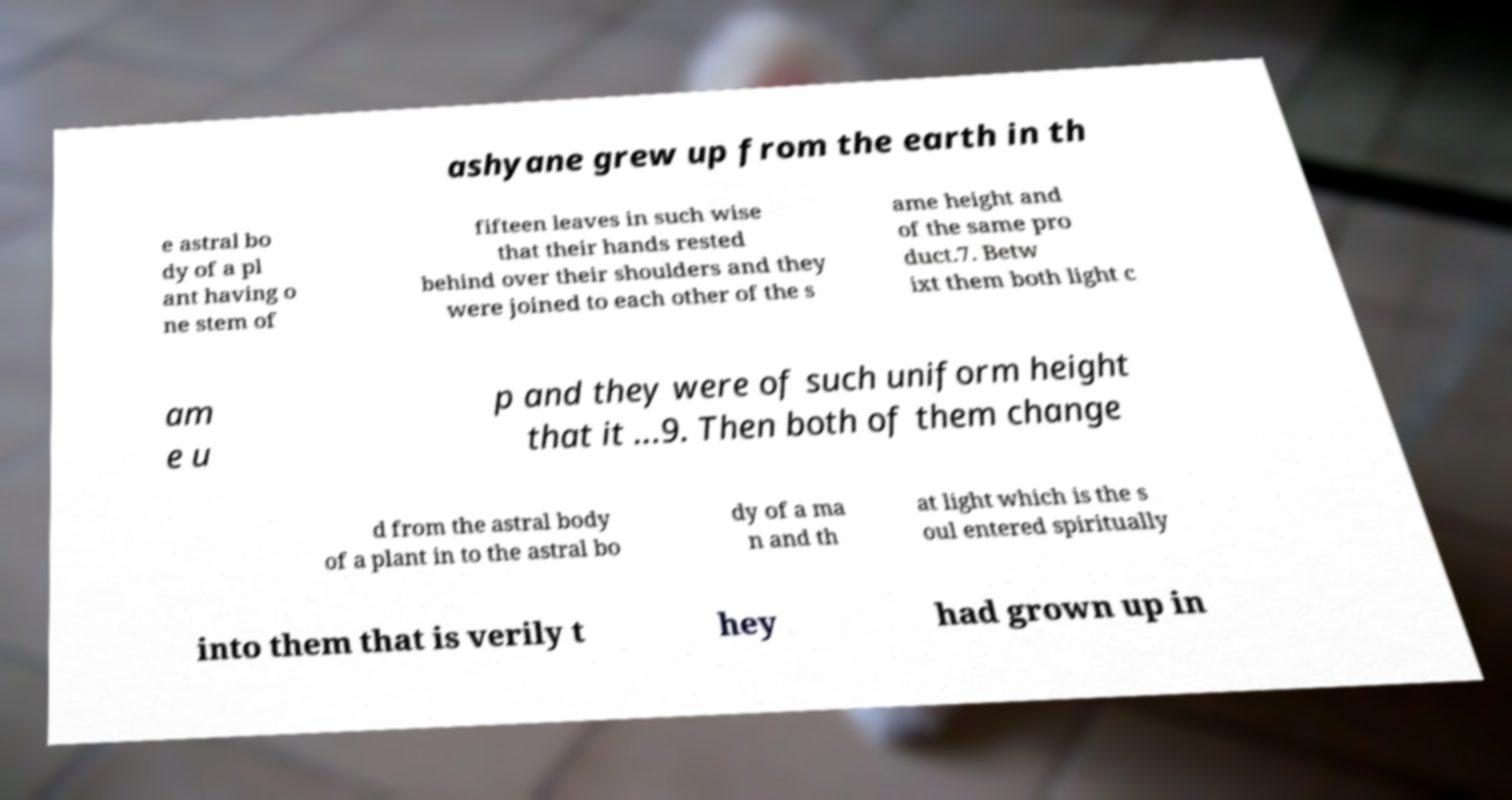Could you extract and type out the text from this image? ashyane grew up from the earth in th e astral bo dy of a pl ant having o ne stem of fifteen leaves in such wise that their hands rested behind over their shoulders and they were joined to each other of the s ame height and of the same pro duct.7. Betw ixt them both light c am e u p and they were of such uniform height that it ...9. Then both of them change d from the astral body of a plant in to the astral bo dy of a ma n and th at light which is the s oul entered spiritually into them that is verily t hey had grown up in 